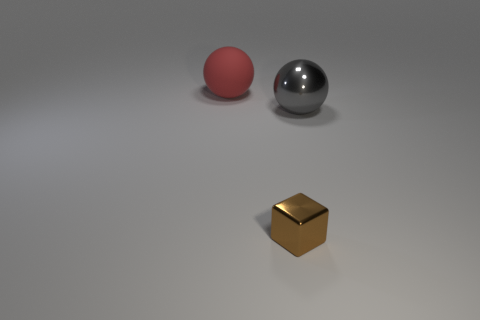What material is the object that is the same size as the red matte ball?
Make the answer very short. Metal. There is a metallic object in front of the gray thing; what is its size?
Provide a short and direct response. Small. Is the size of the ball that is left of the gray metallic sphere the same as the ball right of the small block?
Make the answer very short. Yes. How many objects are the same material as the gray sphere?
Ensure brevity in your answer.  1. What color is the metal sphere?
Your response must be concise. Gray. There is a red thing; are there any large matte objects behind it?
Give a very brief answer. No. Is the tiny block the same color as the matte ball?
Provide a short and direct response. No. What number of matte things have the same color as the small metallic block?
Your response must be concise. 0. There is a sphere on the right side of the big sphere that is behind the gray shiny thing; what size is it?
Offer a very short reply. Large. What is the shape of the large gray object?
Provide a short and direct response. Sphere. 